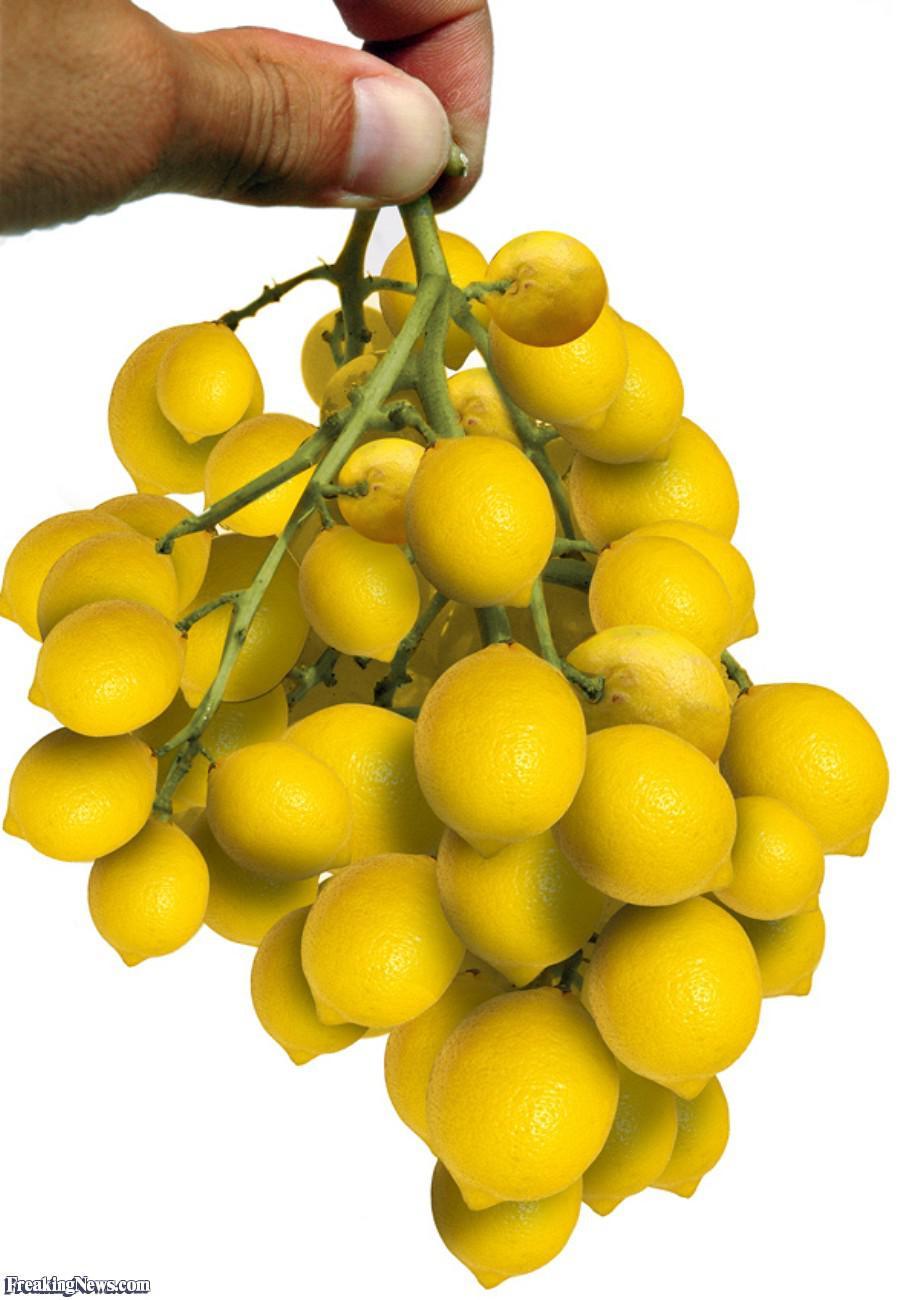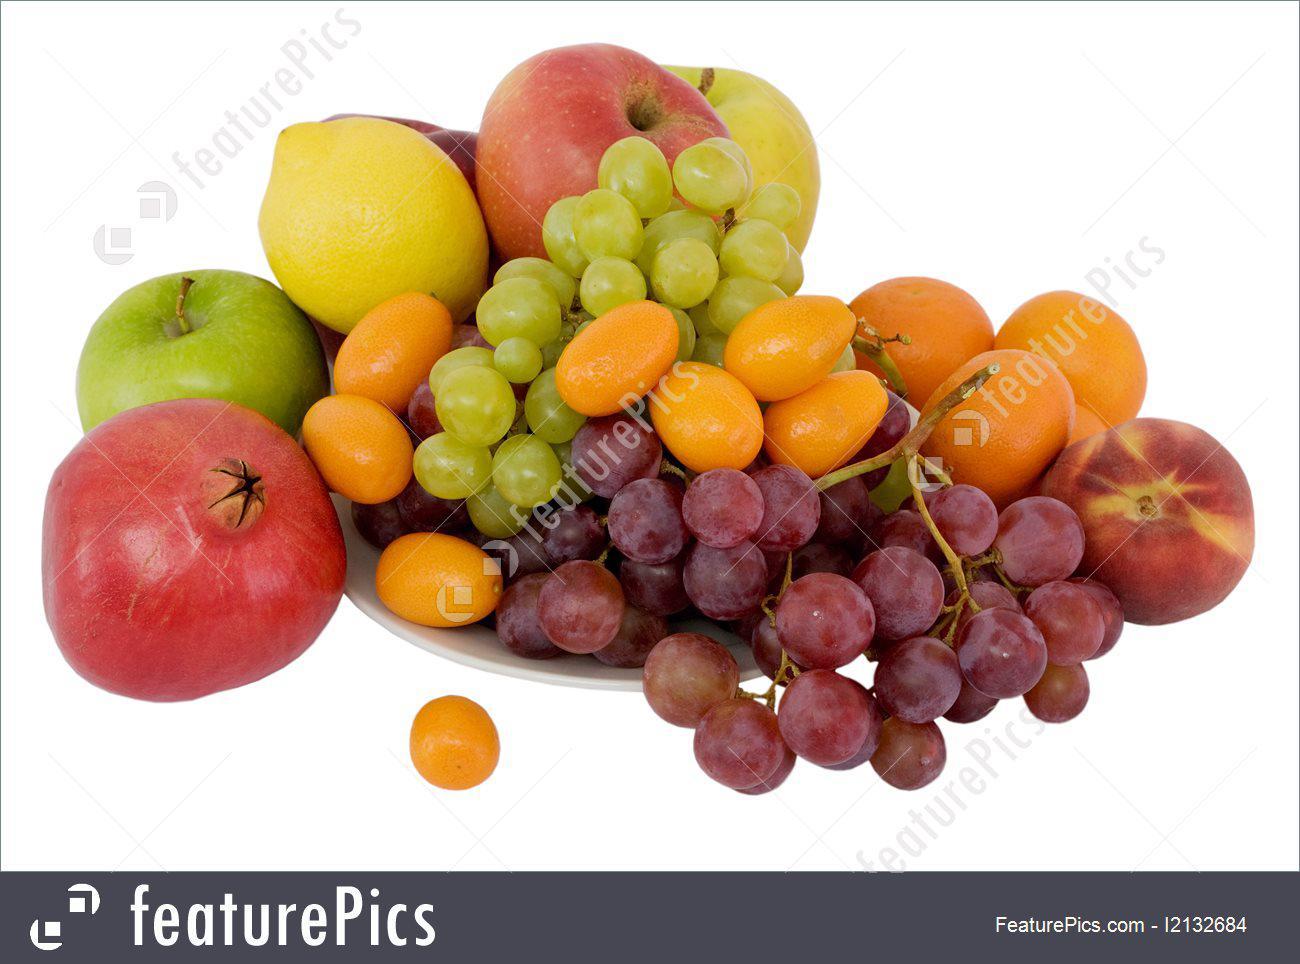The first image is the image on the left, the second image is the image on the right. Assess this claim about the two images: "At least one image features a bunch of purple grapes on the vine.". Correct or not? Answer yes or no. Yes. 